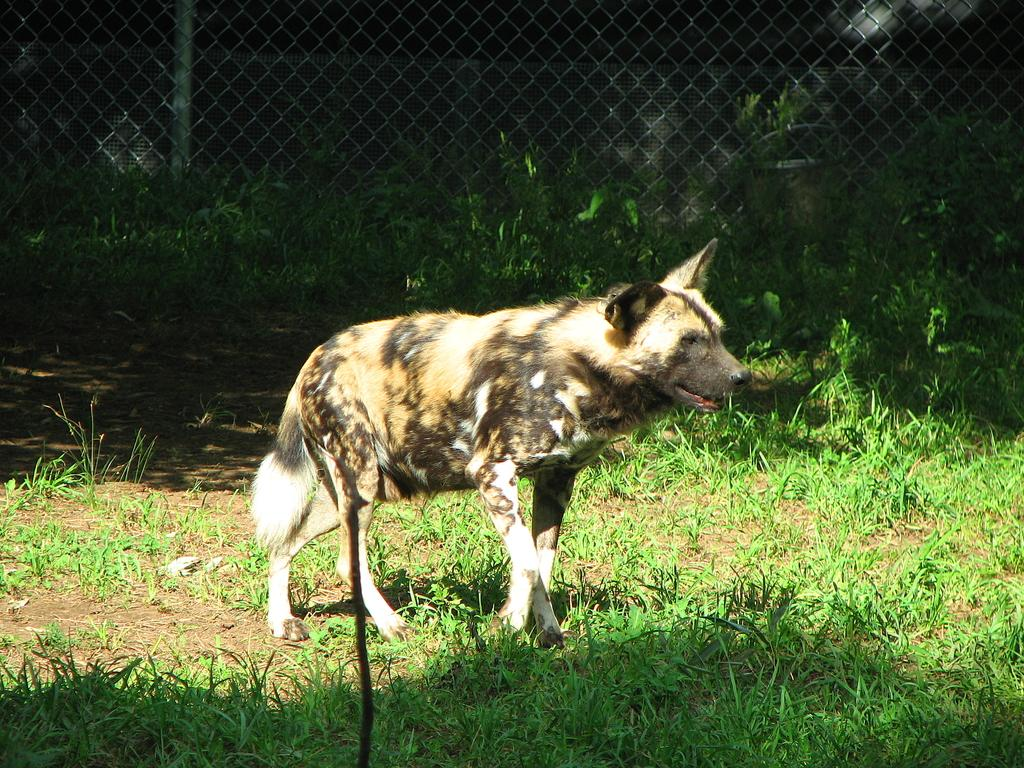What animal is in the center of the image? There is a wild dog in the center of the image. What type of vegetation is at the bottom of the image? There is grass at the bottom of the image. What can be seen in the background of the image? There is a mesh visible in the background of the image. What type of operation is the mom performing on the crib in the image? There is no mom, operation, or crib present in the image. 